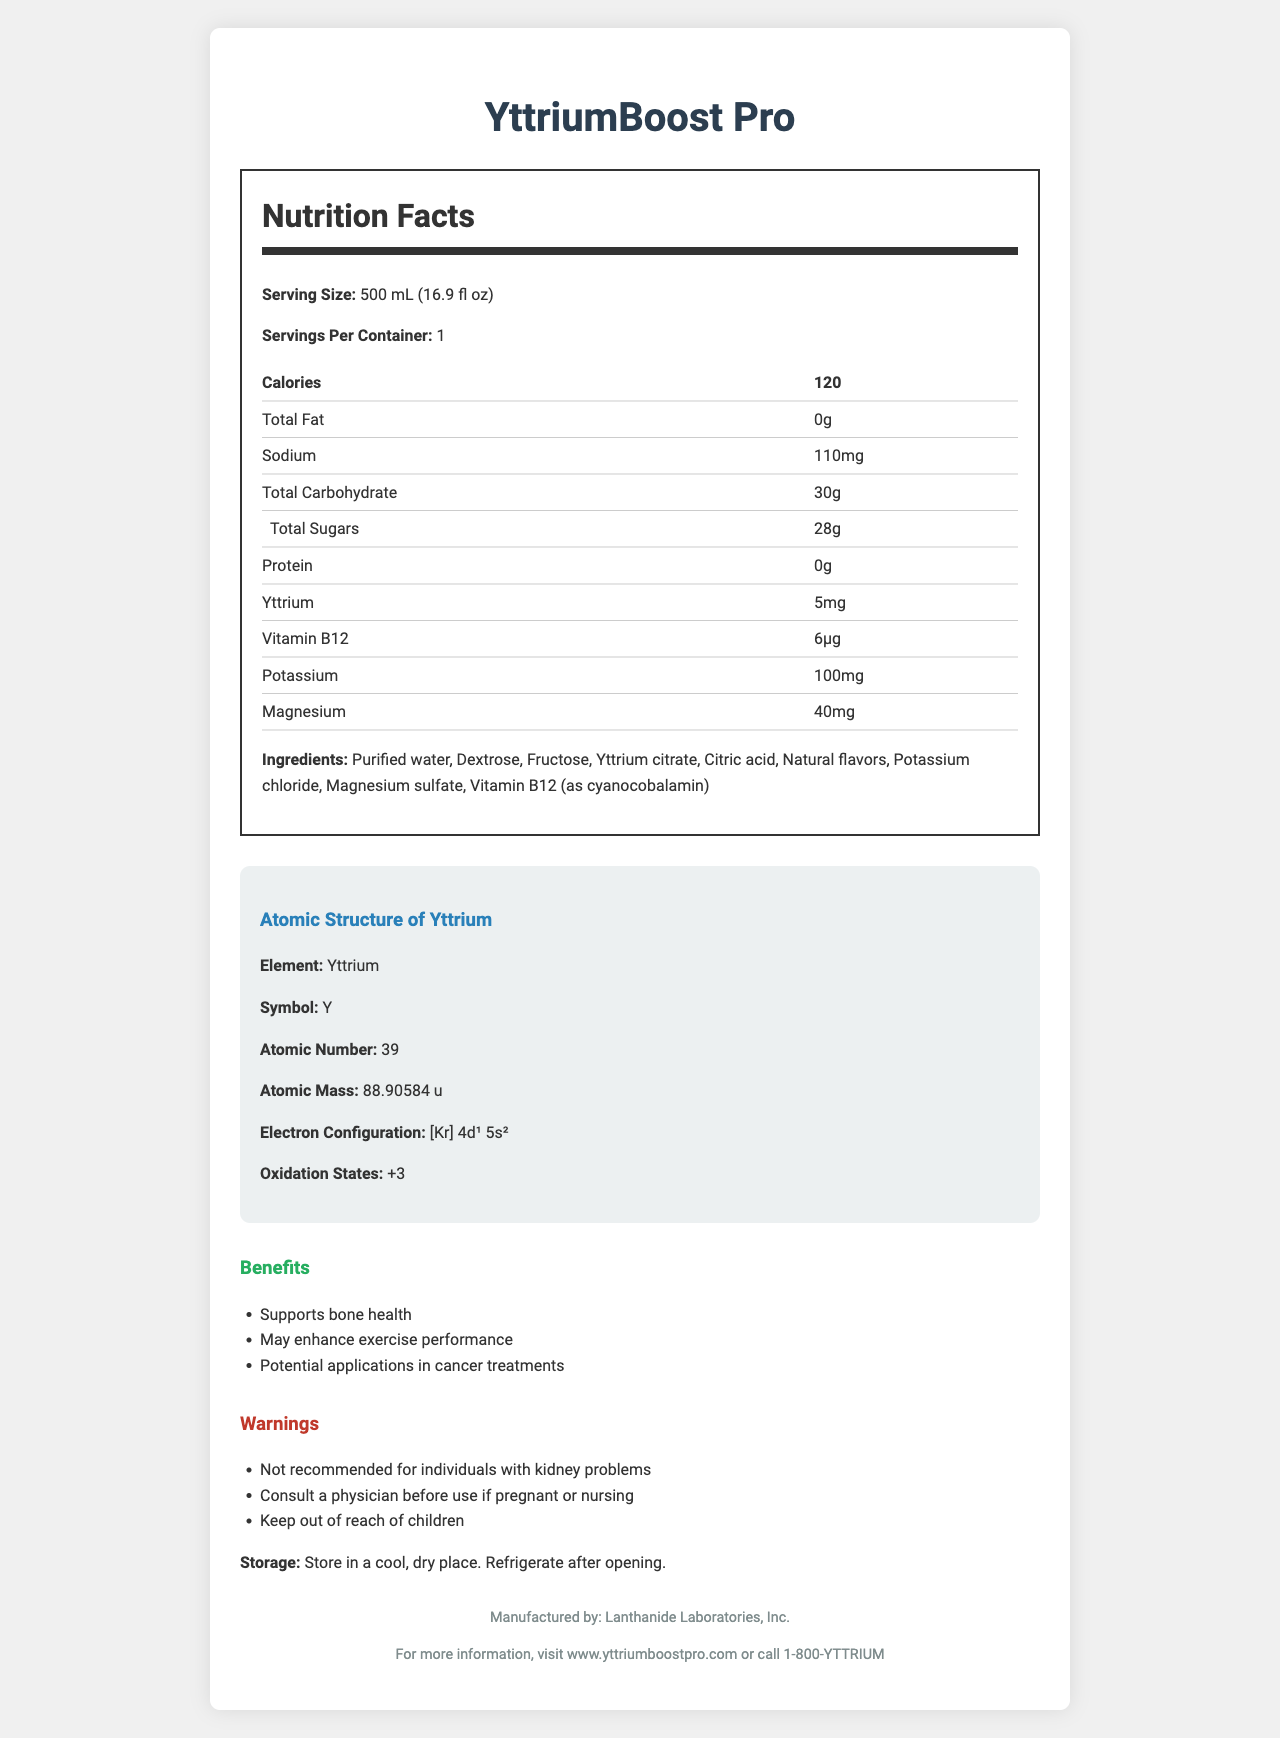what is the serving size of YttriumBoost Pro? The serving size is explicitly mentioned under the "Serving Size" section of the Nutrition Facts.
Answer: 500 mL (16.9 fl oz) how many calories are in a serving of YttriumBoost Pro? The number of calories per serving is listed directly in the Nutrition Facts section.
Answer: 120 what is the primary element highlighted in YttriumBoost Pro’s atomic structure? The primary element is Yttrium, as mentioned in the "Atomic Structure of Yttrium" section.
Answer: Yttrium how much yttrium is in one serving of YttriumBoost Pro? The amount of yttrium per serving is noted in the Nutrition Facts table.
Answer: 5mg how much potassium is in one serving? The potassium content per serving is listed in the Nutrition Facts table.
Answer: 100mg which ingredient provides vitamin B12 in YttriumBoost Pro? The specific source of vitamin B12 is mentioned in the ingredient list.
Answer: Vitamin B12 (as cyanocobalamin) how does YttriumBoost Pro support the body? The health benefits are listed under the "Benefits" section.
Answer: Supports bone health, May enhance exercise performance, Potential applications in cancer treatments what is the atomic number of yttrium? The atomic number is stated in the "Atomic Structure of Yttrium" section.
Answer: 39 which of the following is not an ingredient in YttriumBoost Pro? A. Purified water B. Vitamin D C. Citric acid D. Natural flavors Vitamin D is not listed in the ingredients; the other options are.
Answer: B. Vitamin D what should someone do if they have kidney problems and want to consume YttriumBoost Pro? A. Consult a physician B. Consume in moderation C. Use as directed D. Avoid the drink The warnings state that YttriumBoost Pro is not recommended for individuals with kidney problems.
Answer: D. Avoid the drink is YttriumBoost Pro safe for children? The warning section advises to keep the product out of reach of children.
Answer: No summarize the main idea of the YttriumBoost Pro Nutrition Facts document. The document provides comprehensive information about YttriumBoost Pro, including its nutritional content, health benefits, and safety warnings.
Answer: YttriumBoost Pro is a specialized sports drink enriched with yttrium that offers multiple health benefits such as supporting bone health and enhancing exercise performance. It provides detailed nutritional information, ingredient list, atomic structure of yttrium, and important warnings for specific health conditions. what is the manufacturer of YttriumBoost Pro? The manufacturer is listed at the bottom of the document.
Answer: Lanthanide Laboratories, Inc. how much sodium is in YttriumBoost Pro? The sodium content is directly listed in the Nutrition Facts table.
Answer: 110mg what is the storage instruction for YttriumBoost Pro? The storage instructions are provided beneath the warnings and benefits sections.
Answer: Store in a cool, dry place. Refrigerate after opening. what color is the background of the document? The color of the background is not visually provided in the document description.
Answer: Cannot be determined 